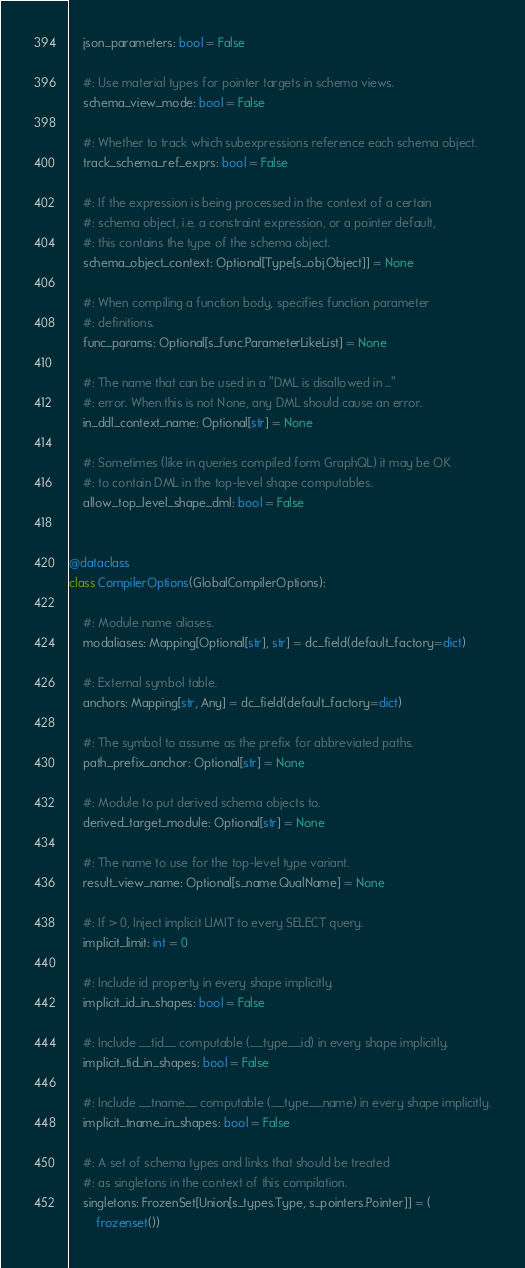<code> <loc_0><loc_0><loc_500><loc_500><_Python_>    json_parameters: bool = False

    #: Use material types for pointer targets in schema views.
    schema_view_mode: bool = False

    #: Whether to track which subexpressions reference each schema object.
    track_schema_ref_exprs: bool = False

    #: If the expression is being processed in the context of a certain
    #: schema object, i.e. a constraint expression, or a pointer default,
    #: this contains the type of the schema object.
    schema_object_context: Optional[Type[s_obj.Object]] = None

    #: When compiling a function body, specifies function parameter
    #: definitions.
    func_params: Optional[s_func.ParameterLikeList] = None

    #: The name that can be used in a "DML is disallowed in ..."
    #: error. When this is not None, any DML should cause an error.
    in_ddl_context_name: Optional[str] = None

    #: Sometimes (like in queries compiled form GraphQL) it may be OK
    #: to contain DML in the top-level shape computables.
    allow_top_level_shape_dml: bool = False


@dataclass
class CompilerOptions(GlobalCompilerOptions):

    #: Module name aliases.
    modaliases: Mapping[Optional[str], str] = dc_field(default_factory=dict)

    #: External symbol table.
    anchors: Mapping[str, Any] = dc_field(default_factory=dict)

    #: The symbol to assume as the prefix for abbreviated paths.
    path_prefix_anchor: Optional[str] = None

    #: Module to put derived schema objects to.
    derived_target_module: Optional[str] = None

    #: The name to use for the top-level type variant.
    result_view_name: Optional[s_name.QualName] = None

    #: If > 0, Inject implicit LIMIT to every SELECT query.
    implicit_limit: int = 0

    #: Include id property in every shape implicitly.
    implicit_id_in_shapes: bool = False

    #: Include __tid__ computable (.__type__.id) in every shape implicitly.
    implicit_tid_in_shapes: bool = False

    #: Include __tname__ computable (.__type__.name) in every shape implicitly.
    implicit_tname_in_shapes: bool = False

    #: A set of schema types and links that should be treated
    #: as singletons in the context of this compilation.
    singletons: FrozenSet[Union[s_types.Type, s_pointers.Pointer]] = (
        frozenset())
</code> 